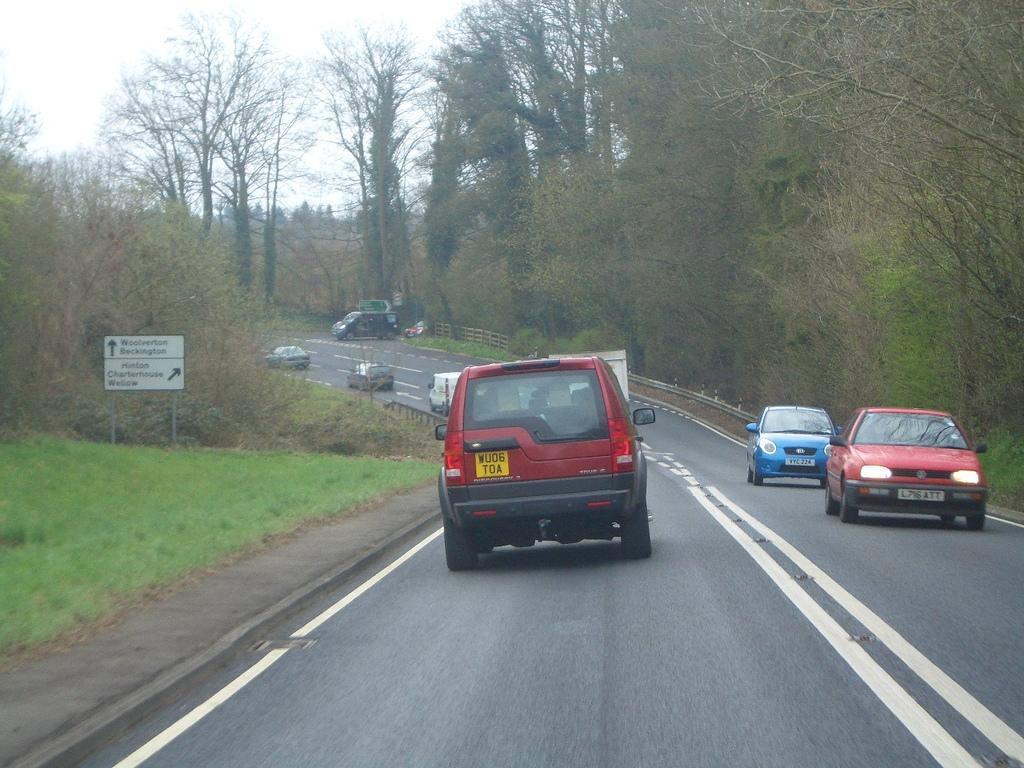Describe this image in one or two sentences. In this image I can see the road. On the road there are many vehicles which are colorful. To the left I can see the board. In the background there are many trees and the white sky. 